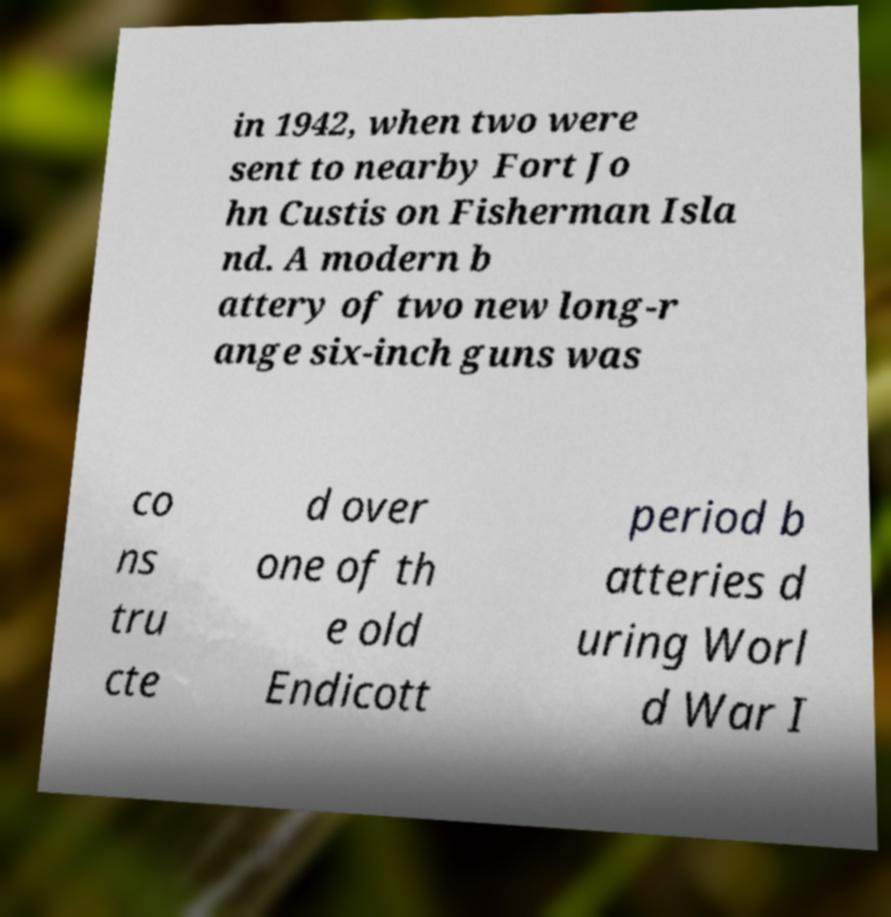There's text embedded in this image that I need extracted. Can you transcribe it verbatim? in 1942, when two were sent to nearby Fort Jo hn Custis on Fisherman Isla nd. A modern b attery of two new long-r ange six-inch guns was co ns tru cte d over one of th e old Endicott period b atteries d uring Worl d War I 